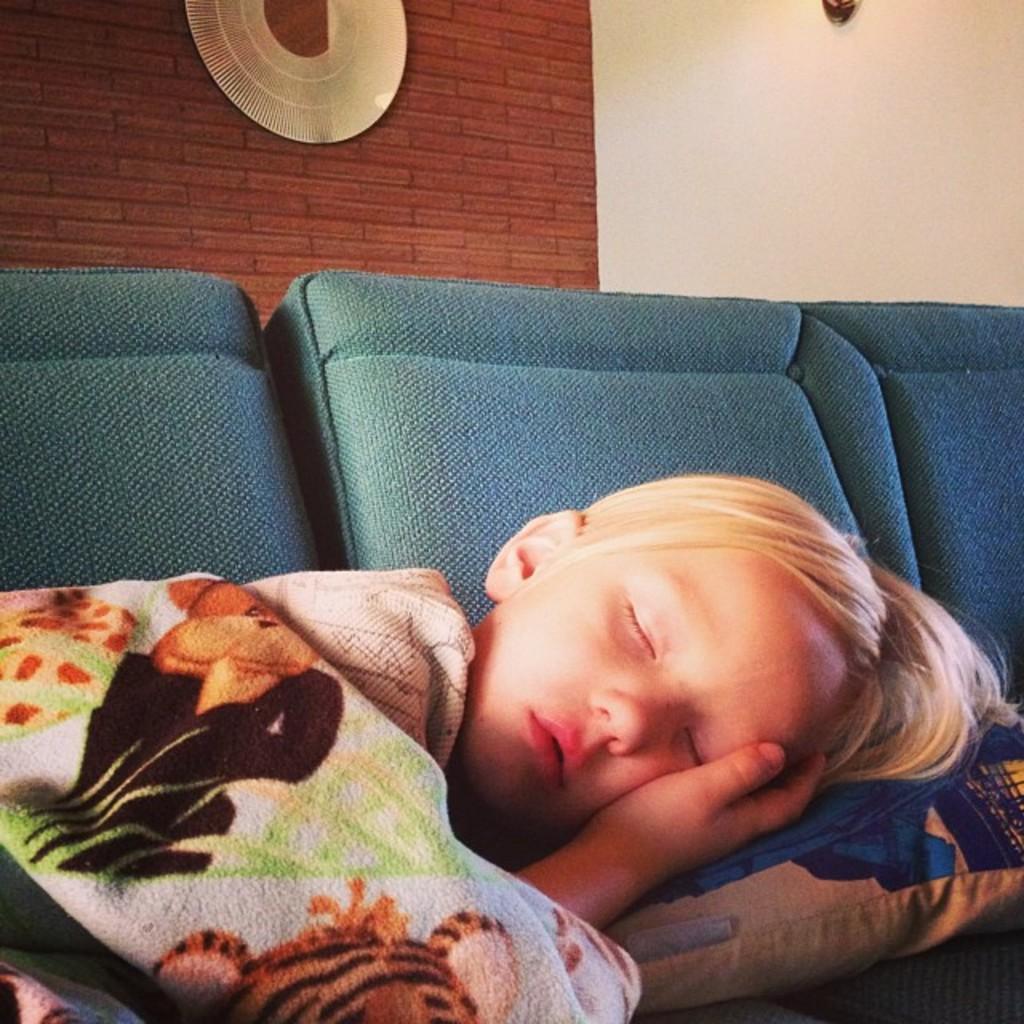In one or two sentences, can you explain what this image depicts? In this image we can see a boy is sleeping on sofa and wearing brown, white, orange and green color blanket. Behind him white and brown color wall is there and some thing is attached to the wall. 